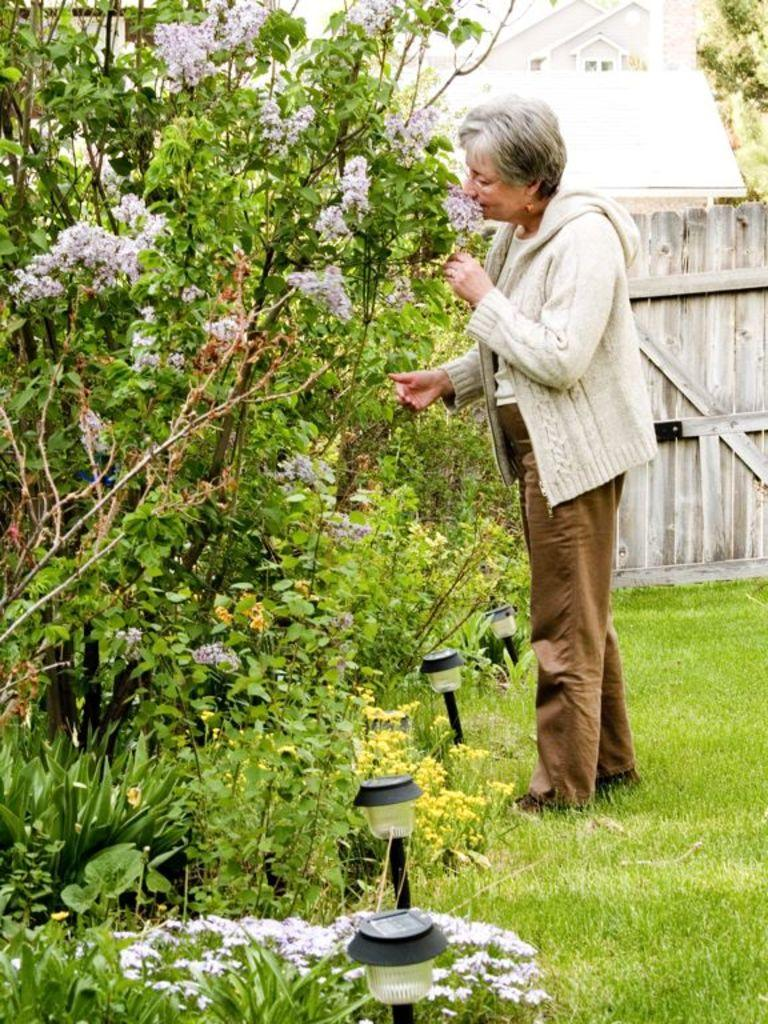What is the woman in the image standing on? The woman is standing on the grass. What type of vegetation can be seen in the image? There are plants and flowers in the image. What can be used to illuminate the area in the image? There are lights in the image. What type of barrier is present in the image? There is a fence in the image. What structure can be seen in the background of the image? There is a house in the background of the image. What type of zebra can be seen interacting with the flowers in the image? There is no zebra present in the image; it only features a woman standing on the grass, plants, flowers, lights, a fence, and a house in the background. 